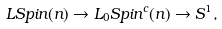Convert formula to latex. <formula><loc_0><loc_0><loc_500><loc_500>L S p i n ( n ) \rightarrow L _ { 0 } S p i n ^ { c } ( n ) \rightarrow S ^ { 1 } ,</formula> 